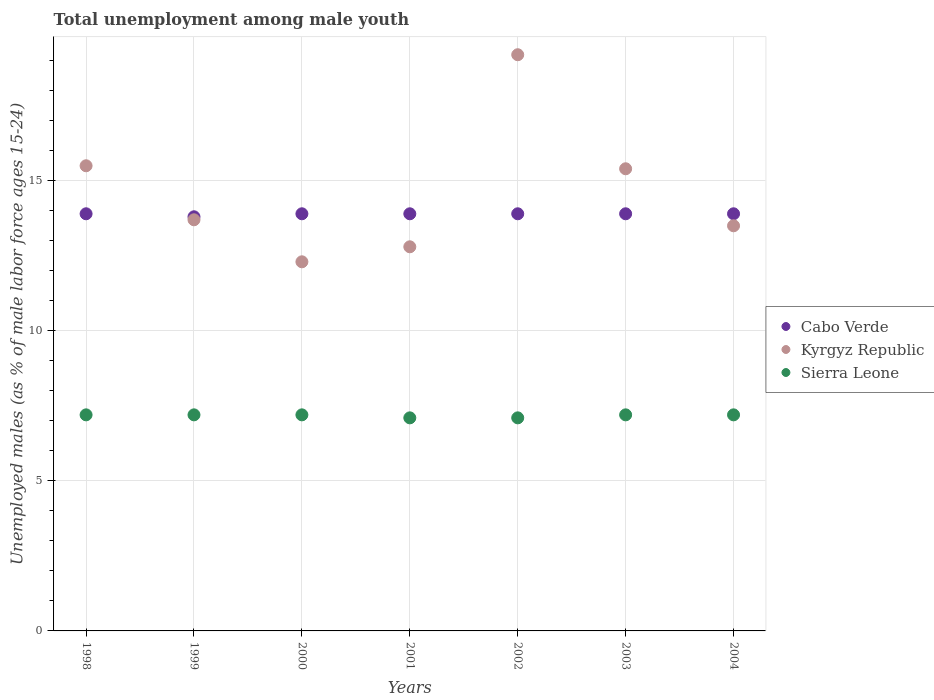Is the number of dotlines equal to the number of legend labels?
Ensure brevity in your answer.  Yes. What is the percentage of unemployed males in in Cabo Verde in 1998?
Ensure brevity in your answer.  13.9. Across all years, what is the maximum percentage of unemployed males in in Cabo Verde?
Your response must be concise. 13.9. Across all years, what is the minimum percentage of unemployed males in in Kyrgyz Republic?
Ensure brevity in your answer.  12.3. In which year was the percentage of unemployed males in in Sierra Leone maximum?
Offer a very short reply. 1998. In which year was the percentage of unemployed males in in Cabo Verde minimum?
Your response must be concise. 1999. What is the total percentage of unemployed males in in Cabo Verde in the graph?
Offer a very short reply. 97.2. What is the difference between the percentage of unemployed males in in Sierra Leone in 2000 and that in 2001?
Your answer should be very brief. 0.1. What is the difference between the percentage of unemployed males in in Cabo Verde in 2004 and the percentage of unemployed males in in Kyrgyz Republic in 2001?
Keep it short and to the point. 1.1. What is the average percentage of unemployed males in in Kyrgyz Republic per year?
Provide a short and direct response. 14.63. In the year 2003, what is the difference between the percentage of unemployed males in in Kyrgyz Republic and percentage of unemployed males in in Sierra Leone?
Offer a terse response. 8.2. In how many years, is the percentage of unemployed males in in Kyrgyz Republic greater than 4 %?
Give a very brief answer. 7. Is the percentage of unemployed males in in Kyrgyz Republic in 1999 less than that in 2001?
Ensure brevity in your answer.  No. What is the difference between the highest and the second highest percentage of unemployed males in in Cabo Verde?
Keep it short and to the point. 0. What is the difference between the highest and the lowest percentage of unemployed males in in Kyrgyz Republic?
Make the answer very short. 6.9. Is the sum of the percentage of unemployed males in in Cabo Verde in 2000 and 2002 greater than the maximum percentage of unemployed males in in Kyrgyz Republic across all years?
Your answer should be very brief. Yes. Is it the case that in every year, the sum of the percentage of unemployed males in in Sierra Leone and percentage of unemployed males in in Cabo Verde  is greater than the percentage of unemployed males in in Kyrgyz Republic?
Provide a short and direct response. Yes. How many dotlines are there?
Keep it short and to the point. 3. What is the difference between two consecutive major ticks on the Y-axis?
Offer a very short reply. 5. Are the values on the major ticks of Y-axis written in scientific E-notation?
Provide a short and direct response. No. Does the graph contain any zero values?
Provide a succinct answer. No. Does the graph contain grids?
Give a very brief answer. Yes. Where does the legend appear in the graph?
Offer a terse response. Center right. How many legend labels are there?
Provide a short and direct response. 3. How are the legend labels stacked?
Make the answer very short. Vertical. What is the title of the graph?
Offer a terse response. Total unemployment among male youth. What is the label or title of the X-axis?
Keep it short and to the point. Years. What is the label or title of the Y-axis?
Your answer should be compact. Unemployed males (as % of male labor force ages 15-24). What is the Unemployed males (as % of male labor force ages 15-24) in Cabo Verde in 1998?
Offer a very short reply. 13.9. What is the Unemployed males (as % of male labor force ages 15-24) of Sierra Leone in 1998?
Ensure brevity in your answer.  7.2. What is the Unemployed males (as % of male labor force ages 15-24) in Cabo Verde in 1999?
Provide a short and direct response. 13.8. What is the Unemployed males (as % of male labor force ages 15-24) of Kyrgyz Republic in 1999?
Give a very brief answer. 13.7. What is the Unemployed males (as % of male labor force ages 15-24) in Sierra Leone in 1999?
Offer a terse response. 7.2. What is the Unemployed males (as % of male labor force ages 15-24) of Cabo Verde in 2000?
Give a very brief answer. 13.9. What is the Unemployed males (as % of male labor force ages 15-24) of Kyrgyz Republic in 2000?
Provide a succinct answer. 12.3. What is the Unemployed males (as % of male labor force ages 15-24) of Sierra Leone in 2000?
Offer a terse response. 7.2. What is the Unemployed males (as % of male labor force ages 15-24) of Cabo Verde in 2001?
Provide a succinct answer. 13.9. What is the Unemployed males (as % of male labor force ages 15-24) of Kyrgyz Republic in 2001?
Keep it short and to the point. 12.8. What is the Unemployed males (as % of male labor force ages 15-24) in Sierra Leone in 2001?
Provide a succinct answer. 7.1. What is the Unemployed males (as % of male labor force ages 15-24) of Cabo Verde in 2002?
Keep it short and to the point. 13.9. What is the Unemployed males (as % of male labor force ages 15-24) of Kyrgyz Republic in 2002?
Provide a succinct answer. 19.2. What is the Unemployed males (as % of male labor force ages 15-24) of Sierra Leone in 2002?
Offer a very short reply. 7.1. What is the Unemployed males (as % of male labor force ages 15-24) in Cabo Verde in 2003?
Your response must be concise. 13.9. What is the Unemployed males (as % of male labor force ages 15-24) of Kyrgyz Republic in 2003?
Provide a succinct answer. 15.4. What is the Unemployed males (as % of male labor force ages 15-24) of Sierra Leone in 2003?
Make the answer very short. 7.2. What is the Unemployed males (as % of male labor force ages 15-24) in Cabo Verde in 2004?
Your answer should be very brief. 13.9. What is the Unemployed males (as % of male labor force ages 15-24) of Kyrgyz Republic in 2004?
Ensure brevity in your answer.  13.5. What is the Unemployed males (as % of male labor force ages 15-24) of Sierra Leone in 2004?
Make the answer very short. 7.2. Across all years, what is the maximum Unemployed males (as % of male labor force ages 15-24) of Cabo Verde?
Offer a terse response. 13.9. Across all years, what is the maximum Unemployed males (as % of male labor force ages 15-24) in Kyrgyz Republic?
Your answer should be very brief. 19.2. Across all years, what is the maximum Unemployed males (as % of male labor force ages 15-24) in Sierra Leone?
Your response must be concise. 7.2. Across all years, what is the minimum Unemployed males (as % of male labor force ages 15-24) in Cabo Verde?
Your answer should be compact. 13.8. Across all years, what is the minimum Unemployed males (as % of male labor force ages 15-24) in Kyrgyz Republic?
Give a very brief answer. 12.3. Across all years, what is the minimum Unemployed males (as % of male labor force ages 15-24) in Sierra Leone?
Make the answer very short. 7.1. What is the total Unemployed males (as % of male labor force ages 15-24) in Cabo Verde in the graph?
Offer a terse response. 97.2. What is the total Unemployed males (as % of male labor force ages 15-24) in Kyrgyz Republic in the graph?
Your answer should be very brief. 102.4. What is the total Unemployed males (as % of male labor force ages 15-24) of Sierra Leone in the graph?
Your answer should be very brief. 50.2. What is the difference between the Unemployed males (as % of male labor force ages 15-24) in Kyrgyz Republic in 1998 and that in 1999?
Your answer should be compact. 1.8. What is the difference between the Unemployed males (as % of male labor force ages 15-24) of Kyrgyz Republic in 1998 and that in 2000?
Keep it short and to the point. 3.2. What is the difference between the Unemployed males (as % of male labor force ages 15-24) of Cabo Verde in 1998 and that in 2001?
Your answer should be very brief. 0. What is the difference between the Unemployed males (as % of male labor force ages 15-24) of Kyrgyz Republic in 1998 and that in 2001?
Your response must be concise. 2.7. What is the difference between the Unemployed males (as % of male labor force ages 15-24) in Cabo Verde in 1998 and that in 2003?
Offer a terse response. 0. What is the difference between the Unemployed males (as % of male labor force ages 15-24) of Kyrgyz Republic in 1998 and that in 2003?
Provide a short and direct response. 0.1. What is the difference between the Unemployed males (as % of male labor force ages 15-24) of Kyrgyz Republic in 1998 and that in 2004?
Your answer should be very brief. 2. What is the difference between the Unemployed males (as % of male labor force ages 15-24) in Cabo Verde in 1999 and that in 2000?
Provide a succinct answer. -0.1. What is the difference between the Unemployed males (as % of male labor force ages 15-24) in Kyrgyz Republic in 1999 and that in 2000?
Make the answer very short. 1.4. What is the difference between the Unemployed males (as % of male labor force ages 15-24) in Sierra Leone in 1999 and that in 2000?
Offer a terse response. 0. What is the difference between the Unemployed males (as % of male labor force ages 15-24) of Kyrgyz Republic in 1999 and that in 2001?
Provide a succinct answer. 0.9. What is the difference between the Unemployed males (as % of male labor force ages 15-24) in Sierra Leone in 1999 and that in 2002?
Keep it short and to the point. 0.1. What is the difference between the Unemployed males (as % of male labor force ages 15-24) in Cabo Verde in 1999 and that in 2003?
Provide a succinct answer. -0.1. What is the difference between the Unemployed males (as % of male labor force ages 15-24) in Kyrgyz Republic in 1999 and that in 2003?
Your answer should be very brief. -1.7. What is the difference between the Unemployed males (as % of male labor force ages 15-24) of Cabo Verde in 1999 and that in 2004?
Give a very brief answer. -0.1. What is the difference between the Unemployed males (as % of male labor force ages 15-24) of Cabo Verde in 2000 and that in 2001?
Your answer should be compact. 0. What is the difference between the Unemployed males (as % of male labor force ages 15-24) of Sierra Leone in 2000 and that in 2001?
Provide a succinct answer. 0.1. What is the difference between the Unemployed males (as % of male labor force ages 15-24) of Sierra Leone in 2000 and that in 2002?
Provide a short and direct response. 0.1. What is the difference between the Unemployed males (as % of male labor force ages 15-24) in Sierra Leone in 2000 and that in 2003?
Give a very brief answer. 0. What is the difference between the Unemployed males (as % of male labor force ages 15-24) in Cabo Verde in 2000 and that in 2004?
Provide a short and direct response. 0. What is the difference between the Unemployed males (as % of male labor force ages 15-24) of Sierra Leone in 2000 and that in 2004?
Your response must be concise. 0. What is the difference between the Unemployed males (as % of male labor force ages 15-24) in Kyrgyz Republic in 2001 and that in 2002?
Offer a very short reply. -6.4. What is the difference between the Unemployed males (as % of male labor force ages 15-24) of Sierra Leone in 2001 and that in 2002?
Your answer should be very brief. 0. What is the difference between the Unemployed males (as % of male labor force ages 15-24) of Sierra Leone in 2001 and that in 2004?
Your answer should be compact. -0.1. What is the difference between the Unemployed males (as % of male labor force ages 15-24) of Cabo Verde in 2002 and that in 2003?
Keep it short and to the point. 0. What is the difference between the Unemployed males (as % of male labor force ages 15-24) of Kyrgyz Republic in 2002 and that in 2003?
Ensure brevity in your answer.  3.8. What is the difference between the Unemployed males (as % of male labor force ages 15-24) in Cabo Verde in 2002 and that in 2004?
Give a very brief answer. 0. What is the difference between the Unemployed males (as % of male labor force ages 15-24) in Kyrgyz Republic in 2002 and that in 2004?
Provide a short and direct response. 5.7. What is the difference between the Unemployed males (as % of male labor force ages 15-24) of Sierra Leone in 2002 and that in 2004?
Your answer should be very brief. -0.1. What is the difference between the Unemployed males (as % of male labor force ages 15-24) of Sierra Leone in 2003 and that in 2004?
Offer a very short reply. 0. What is the difference between the Unemployed males (as % of male labor force ages 15-24) in Cabo Verde in 1998 and the Unemployed males (as % of male labor force ages 15-24) in Kyrgyz Republic in 1999?
Keep it short and to the point. 0.2. What is the difference between the Unemployed males (as % of male labor force ages 15-24) of Kyrgyz Republic in 1998 and the Unemployed males (as % of male labor force ages 15-24) of Sierra Leone in 1999?
Ensure brevity in your answer.  8.3. What is the difference between the Unemployed males (as % of male labor force ages 15-24) of Cabo Verde in 1998 and the Unemployed males (as % of male labor force ages 15-24) of Sierra Leone in 2000?
Your answer should be compact. 6.7. What is the difference between the Unemployed males (as % of male labor force ages 15-24) in Kyrgyz Republic in 1998 and the Unemployed males (as % of male labor force ages 15-24) in Sierra Leone in 2000?
Offer a very short reply. 8.3. What is the difference between the Unemployed males (as % of male labor force ages 15-24) of Kyrgyz Republic in 1998 and the Unemployed males (as % of male labor force ages 15-24) of Sierra Leone in 2001?
Give a very brief answer. 8.4. What is the difference between the Unemployed males (as % of male labor force ages 15-24) in Cabo Verde in 1998 and the Unemployed males (as % of male labor force ages 15-24) in Kyrgyz Republic in 2002?
Make the answer very short. -5.3. What is the difference between the Unemployed males (as % of male labor force ages 15-24) of Cabo Verde in 1998 and the Unemployed males (as % of male labor force ages 15-24) of Sierra Leone in 2002?
Provide a succinct answer. 6.8. What is the difference between the Unemployed males (as % of male labor force ages 15-24) of Cabo Verde in 1998 and the Unemployed males (as % of male labor force ages 15-24) of Kyrgyz Republic in 2003?
Offer a terse response. -1.5. What is the difference between the Unemployed males (as % of male labor force ages 15-24) of Cabo Verde in 1998 and the Unemployed males (as % of male labor force ages 15-24) of Sierra Leone in 2003?
Your answer should be compact. 6.7. What is the difference between the Unemployed males (as % of male labor force ages 15-24) in Cabo Verde in 1998 and the Unemployed males (as % of male labor force ages 15-24) in Kyrgyz Republic in 2004?
Keep it short and to the point. 0.4. What is the difference between the Unemployed males (as % of male labor force ages 15-24) of Kyrgyz Republic in 1998 and the Unemployed males (as % of male labor force ages 15-24) of Sierra Leone in 2004?
Your answer should be very brief. 8.3. What is the difference between the Unemployed males (as % of male labor force ages 15-24) of Kyrgyz Republic in 1999 and the Unemployed males (as % of male labor force ages 15-24) of Sierra Leone in 2000?
Give a very brief answer. 6.5. What is the difference between the Unemployed males (as % of male labor force ages 15-24) of Cabo Verde in 1999 and the Unemployed males (as % of male labor force ages 15-24) of Sierra Leone in 2001?
Keep it short and to the point. 6.7. What is the difference between the Unemployed males (as % of male labor force ages 15-24) in Cabo Verde in 1999 and the Unemployed males (as % of male labor force ages 15-24) in Sierra Leone in 2002?
Provide a succinct answer. 6.7. What is the difference between the Unemployed males (as % of male labor force ages 15-24) in Kyrgyz Republic in 1999 and the Unemployed males (as % of male labor force ages 15-24) in Sierra Leone in 2002?
Provide a short and direct response. 6.6. What is the difference between the Unemployed males (as % of male labor force ages 15-24) in Kyrgyz Republic in 1999 and the Unemployed males (as % of male labor force ages 15-24) in Sierra Leone in 2003?
Offer a very short reply. 6.5. What is the difference between the Unemployed males (as % of male labor force ages 15-24) in Cabo Verde in 1999 and the Unemployed males (as % of male labor force ages 15-24) in Kyrgyz Republic in 2004?
Provide a succinct answer. 0.3. What is the difference between the Unemployed males (as % of male labor force ages 15-24) of Kyrgyz Republic in 1999 and the Unemployed males (as % of male labor force ages 15-24) of Sierra Leone in 2004?
Make the answer very short. 6.5. What is the difference between the Unemployed males (as % of male labor force ages 15-24) of Cabo Verde in 2000 and the Unemployed males (as % of male labor force ages 15-24) of Sierra Leone in 2001?
Your answer should be very brief. 6.8. What is the difference between the Unemployed males (as % of male labor force ages 15-24) in Kyrgyz Republic in 2000 and the Unemployed males (as % of male labor force ages 15-24) in Sierra Leone in 2001?
Offer a terse response. 5.2. What is the difference between the Unemployed males (as % of male labor force ages 15-24) of Cabo Verde in 2000 and the Unemployed males (as % of male labor force ages 15-24) of Kyrgyz Republic in 2002?
Your response must be concise. -5.3. What is the difference between the Unemployed males (as % of male labor force ages 15-24) of Kyrgyz Republic in 2000 and the Unemployed males (as % of male labor force ages 15-24) of Sierra Leone in 2002?
Offer a terse response. 5.2. What is the difference between the Unemployed males (as % of male labor force ages 15-24) of Cabo Verde in 2000 and the Unemployed males (as % of male labor force ages 15-24) of Sierra Leone in 2003?
Give a very brief answer. 6.7. What is the difference between the Unemployed males (as % of male labor force ages 15-24) in Kyrgyz Republic in 2000 and the Unemployed males (as % of male labor force ages 15-24) in Sierra Leone in 2003?
Make the answer very short. 5.1. What is the difference between the Unemployed males (as % of male labor force ages 15-24) in Cabo Verde in 2000 and the Unemployed males (as % of male labor force ages 15-24) in Kyrgyz Republic in 2004?
Offer a very short reply. 0.4. What is the difference between the Unemployed males (as % of male labor force ages 15-24) of Cabo Verde in 2000 and the Unemployed males (as % of male labor force ages 15-24) of Sierra Leone in 2004?
Your response must be concise. 6.7. What is the difference between the Unemployed males (as % of male labor force ages 15-24) of Cabo Verde in 2001 and the Unemployed males (as % of male labor force ages 15-24) of Kyrgyz Republic in 2002?
Keep it short and to the point. -5.3. What is the difference between the Unemployed males (as % of male labor force ages 15-24) in Cabo Verde in 2001 and the Unemployed males (as % of male labor force ages 15-24) in Sierra Leone in 2002?
Give a very brief answer. 6.8. What is the difference between the Unemployed males (as % of male labor force ages 15-24) of Kyrgyz Republic in 2001 and the Unemployed males (as % of male labor force ages 15-24) of Sierra Leone in 2002?
Offer a very short reply. 5.7. What is the difference between the Unemployed males (as % of male labor force ages 15-24) of Cabo Verde in 2001 and the Unemployed males (as % of male labor force ages 15-24) of Kyrgyz Republic in 2003?
Offer a terse response. -1.5. What is the difference between the Unemployed males (as % of male labor force ages 15-24) of Cabo Verde in 2001 and the Unemployed males (as % of male labor force ages 15-24) of Kyrgyz Republic in 2004?
Provide a short and direct response. 0.4. What is the difference between the Unemployed males (as % of male labor force ages 15-24) of Cabo Verde in 2001 and the Unemployed males (as % of male labor force ages 15-24) of Sierra Leone in 2004?
Offer a terse response. 6.7. What is the difference between the Unemployed males (as % of male labor force ages 15-24) of Kyrgyz Republic in 2001 and the Unemployed males (as % of male labor force ages 15-24) of Sierra Leone in 2004?
Provide a short and direct response. 5.6. What is the difference between the Unemployed males (as % of male labor force ages 15-24) of Cabo Verde in 2002 and the Unemployed males (as % of male labor force ages 15-24) of Kyrgyz Republic in 2003?
Give a very brief answer. -1.5. What is the difference between the Unemployed males (as % of male labor force ages 15-24) in Kyrgyz Republic in 2002 and the Unemployed males (as % of male labor force ages 15-24) in Sierra Leone in 2003?
Provide a short and direct response. 12. What is the difference between the Unemployed males (as % of male labor force ages 15-24) of Cabo Verde in 2002 and the Unemployed males (as % of male labor force ages 15-24) of Kyrgyz Republic in 2004?
Offer a very short reply. 0.4. What is the difference between the Unemployed males (as % of male labor force ages 15-24) in Cabo Verde in 2002 and the Unemployed males (as % of male labor force ages 15-24) in Sierra Leone in 2004?
Your answer should be very brief. 6.7. What is the difference between the Unemployed males (as % of male labor force ages 15-24) of Kyrgyz Republic in 2002 and the Unemployed males (as % of male labor force ages 15-24) of Sierra Leone in 2004?
Your answer should be very brief. 12. What is the difference between the Unemployed males (as % of male labor force ages 15-24) in Cabo Verde in 2003 and the Unemployed males (as % of male labor force ages 15-24) in Kyrgyz Republic in 2004?
Your response must be concise. 0.4. What is the difference between the Unemployed males (as % of male labor force ages 15-24) in Cabo Verde in 2003 and the Unemployed males (as % of male labor force ages 15-24) in Sierra Leone in 2004?
Give a very brief answer. 6.7. What is the average Unemployed males (as % of male labor force ages 15-24) of Cabo Verde per year?
Your answer should be very brief. 13.89. What is the average Unemployed males (as % of male labor force ages 15-24) of Kyrgyz Republic per year?
Ensure brevity in your answer.  14.63. What is the average Unemployed males (as % of male labor force ages 15-24) of Sierra Leone per year?
Keep it short and to the point. 7.17. In the year 1998, what is the difference between the Unemployed males (as % of male labor force ages 15-24) of Kyrgyz Republic and Unemployed males (as % of male labor force ages 15-24) of Sierra Leone?
Make the answer very short. 8.3. In the year 1999, what is the difference between the Unemployed males (as % of male labor force ages 15-24) in Cabo Verde and Unemployed males (as % of male labor force ages 15-24) in Kyrgyz Republic?
Offer a terse response. 0.1. In the year 2000, what is the difference between the Unemployed males (as % of male labor force ages 15-24) of Cabo Verde and Unemployed males (as % of male labor force ages 15-24) of Kyrgyz Republic?
Your answer should be very brief. 1.6. In the year 2000, what is the difference between the Unemployed males (as % of male labor force ages 15-24) of Cabo Verde and Unemployed males (as % of male labor force ages 15-24) of Sierra Leone?
Provide a short and direct response. 6.7. In the year 2001, what is the difference between the Unemployed males (as % of male labor force ages 15-24) in Cabo Verde and Unemployed males (as % of male labor force ages 15-24) in Kyrgyz Republic?
Your answer should be compact. 1.1. In the year 2001, what is the difference between the Unemployed males (as % of male labor force ages 15-24) of Cabo Verde and Unemployed males (as % of male labor force ages 15-24) of Sierra Leone?
Your response must be concise. 6.8. In the year 2001, what is the difference between the Unemployed males (as % of male labor force ages 15-24) in Kyrgyz Republic and Unemployed males (as % of male labor force ages 15-24) in Sierra Leone?
Provide a short and direct response. 5.7. In the year 2002, what is the difference between the Unemployed males (as % of male labor force ages 15-24) of Cabo Verde and Unemployed males (as % of male labor force ages 15-24) of Kyrgyz Republic?
Ensure brevity in your answer.  -5.3. In the year 2002, what is the difference between the Unemployed males (as % of male labor force ages 15-24) of Kyrgyz Republic and Unemployed males (as % of male labor force ages 15-24) of Sierra Leone?
Provide a short and direct response. 12.1. In the year 2003, what is the difference between the Unemployed males (as % of male labor force ages 15-24) of Cabo Verde and Unemployed males (as % of male labor force ages 15-24) of Kyrgyz Republic?
Provide a short and direct response. -1.5. In the year 2003, what is the difference between the Unemployed males (as % of male labor force ages 15-24) in Cabo Verde and Unemployed males (as % of male labor force ages 15-24) in Sierra Leone?
Give a very brief answer. 6.7. In the year 2003, what is the difference between the Unemployed males (as % of male labor force ages 15-24) in Kyrgyz Republic and Unemployed males (as % of male labor force ages 15-24) in Sierra Leone?
Provide a succinct answer. 8.2. In the year 2004, what is the difference between the Unemployed males (as % of male labor force ages 15-24) of Cabo Verde and Unemployed males (as % of male labor force ages 15-24) of Kyrgyz Republic?
Make the answer very short. 0.4. In the year 2004, what is the difference between the Unemployed males (as % of male labor force ages 15-24) of Cabo Verde and Unemployed males (as % of male labor force ages 15-24) of Sierra Leone?
Your response must be concise. 6.7. In the year 2004, what is the difference between the Unemployed males (as % of male labor force ages 15-24) in Kyrgyz Republic and Unemployed males (as % of male labor force ages 15-24) in Sierra Leone?
Offer a terse response. 6.3. What is the ratio of the Unemployed males (as % of male labor force ages 15-24) in Cabo Verde in 1998 to that in 1999?
Ensure brevity in your answer.  1.01. What is the ratio of the Unemployed males (as % of male labor force ages 15-24) in Kyrgyz Republic in 1998 to that in 1999?
Your answer should be compact. 1.13. What is the ratio of the Unemployed males (as % of male labor force ages 15-24) of Kyrgyz Republic in 1998 to that in 2000?
Your response must be concise. 1.26. What is the ratio of the Unemployed males (as % of male labor force ages 15-24) of Kyrgyz Republic in 1998 to that in 2001?
Your answer should be very brief. 1.21. What is the ratio of the Unemployed males (as % of male labor force ages 15-24) of Sierra Leone in 1998 to that in 2001?
Give a very brief answer. 1.01. What is the ratio of the Unemployed males (as % of male labor force ages 15-24) in Cabo Verde in 1998 to that in 2002?
Your answer should be compact. 1. What is the ratio of the Unemployed males (as % of male labor force ages 15-24) in Kyrgyz Republic in 1998 to that in 2002?
Keep it short and to the point. 0.81. What is the ratio of the Unemployed males (as % of male labor force ages 15-24) in Sierra Leone in 1998 to that in 2002?
Your answer should be compact. 1.01. What is the ratio of the Unemployed males (as % of male labor force ages 15-24) in Kyrgyz Republic in 1998 to that in 2003?
Give a very brief answer. 1.01. What is the ratio of the Unemployed males (as % of male labor force ages 15-24) in Kyrgyz Republic in 1998 to that in 2004?
Your answer should be very brief. 1.15. What is the ratio of the Unemployed males (as % of male labor force ages 15-24) of Kyrgyz Republic in 1999 to that in 2000?
Offer a very short reply. 1.11. What is the ratio of the Unemployed males (as % of male labor force ages 15-24) in Sierra Leone in 1999 to that in 2000?
Your answer should be compact. 1. What is the ratio of the Unemployed males (as % of male labor force ages 15-24) in Cabo Verde in 1999 to that in 2001?
Provide a short and direct response. 0.99. What is the ratio of the Unemployed males (as % of male labor force ages 15-24) of Kyrgyz Republic in 1999 to that in 2001?
Offer a terse response. 1.07. What is the ratio of the Unemployed males (as % of male labor force ages 15-24) in Sierra Leone in 1999 to that in 2001?
Keep it short and to the point. 1.01. What is the ratio of the Unemployed males (as % of male labor force ages 15-24) in Kyrgyz Republic in 1999 to that in 2002?
Give a very brief answer. 0.71. What is the ratio of the Unemployed males (as % of male labor force ages 15-24) of Sierra Leone in 1999 to that in 2002?
Your answer should be compact. 1.01. What is the ratio of the Unemployed males (as % of male labor force ages 15-24) of Cabo Verde in 1999 to that in 2003?
Provide a short and direct response. 0.99. What is the ratio of the Unemployed males (as % of male labor force ages 15-24) of Kyrgyz Republic in 1999 to that in 2003?
Your answer should be compact. 0.89. What is the ratio of the Unemployed males (as % of male labor force ages 15-24) of Sierra Leone in 1999 to that in 2003?
Offer a very short reply. 1. What is the ratio of the Unemployed males (as % of male labor force ages 15-24) in Cabo Verde in 1999 to that in 2004?
Provide a succinct answer. 0.99. What is the ratio of the Unemployed males (as % of male labor force ages 15-24) in Kyrgyz Republic in 1999 to that in 2004?
Offer a terse response. 1.01. What is the ratio of the Unemployed males (as % of male labor force ages 15-24) in Sierra Leone in 1999 to that in 2004?
Give a very brief answer. 1. What is the ratio of the Unemployed males (as % of male labor force ages 15-24) of Kyrgyz Republic in 2000 to that in 2001?
Provide a succinct answer. 0.96. What is the ratio of the Unemployed males (as % of male labor force ages 15-24) in Sierra Leone in 2000 to that in 2001?
Keep it short and to the point. 1.01. What is the ratio of the Unemployed males (as % of male labor force ages 15-24) in Kyrgyz Republic in 2000 to that in 2002?
Your answer should be very brief. 0.64. What is the ratio of the Unemployed males (as % of male labor force ages 15-24) of Sierra Leone in 2000 to that in 2002?
Give a very brief answer. 1.01. What is the ratio of the Unemployed males (as % of male labor force ages 15-24) of Kyrgyz Republic in 2000 to that in 2003?
Offer a terse response. 0.8. What is the ratio of the Unemployed males (as % of male labor force ages 15-24) in Cabo Verde in 2000 to that in 2004?
Make the answer very short. 1. What is the ratio of the Unemployed males (as % of male labor force ages 15-24) in Kyrgyz Republic in 2000 to that in 2004?
Provide a short and direct response. 0.91. What is the ratio of the Unemployed males (as % of male labor force ages 15-24) of Sierra Leone in 2000 to that in 2004?
Your answer should be compact. 1. What is the ratio of the Unemployed males (as % of male labor force ages 15-24) in Kyrgyz Republic in 2001 to that in 2002?
Keep it short and to the point. 0.67. What is the ratio of the Unemployed males (as % of male labor force ages 15-24) of Sierra Leone in 2001 to that in 2002?
Provide a short and direct response. 1. What is the ratio of the Unemployed males (as % of male labor force ages 15-24) in Cabo Verde in 2001 to that in 2003?
Make the answer very short. 1. What is the ratio of the Unemployed males (as % of male labor force ages 15-24) of Kyrgyz Republic in 2001 to that in 2003?
Your answer should be compact. 0.83. What is the ratio of the Unemployed males (as % of male labor force ages 15-24) in Sierra Leone in 2001 to that in 2003?
Your answer should be very brief. 0.99. What is the ratio of the Unemployed males (as % of male labor force ages 15-24) in Cabo Verde in 2001 to that in 2004?
Make the answer very short. 1. What is the ratio of the Unemployed males (as % of male labor force ages 15-24) of Kyrgyz Republic in 2001 to that in 2004?
Your response must be concise. 0.95. What is the ratio of the Unemployed males (as % of male labor force ages 15-24) of Sierra Leone in 2001 to that in 2004?
Offer a terse response. 0.99. What is the ratio of the Unemployed males (as % of male labor force ages 15-24) in Cabo Verde in 2002 to that in 2003?
Provide a short and direct response. 1. What is the ratio of the Unemployed males (as % of male labor force ages 15-24) in Kyrgyz Republic in 2002 to that in 2003?
Your response must be concise. 1.25. What is the ratio of the Unemployed males (as % of male labor force ages 15-24) of Sierra Leone in 2002 to that in 2003?
Provide a short and direct response. 0.99. What is the ratio of the Unemployed males (as % of male labor force ages 15-24) of Cabo Verde in 2002 to that in 2004?
Your response must be concise. 1. What is the ratio of the Unemployed males (as % of male labor force ages 15-24) in Kyrgyz Republic in 2002 to that in 2004?
Your answer should be compact. 1.42. What is the ratio of the Unemployed males (as % of male labor force ages 15-24) in Sierra Leone in 2002 to that in 2004?
Ensure brevity in your answer.  0.99. What is the ratio of the Unemployed males (as % of male labor force ages 15-24) in Kyrgyz Republic in 2003 to that in 2004?
Provide a short and direct response. 1.14. What is the ratio of the Unemployed males (as % of male labor force ages 15-24) of Sierra Leone in 2003 to that in 2004?
Offer a terse response. 1. What is the difference between the highest and the second highest Unemployed males (as % of male labor force ages 15-24) of Cabo Verde?
Offer a terse response. 0. What is the difference between the highest and the second highest Unemployed males (as % of male labor force ages 15-24) in Sierra Leone?
Make the answer very short. 0. What is the difference between the highest and the lowest Unemployed males (as % of male labor force ages 15-24) of Cabo Verde?
Offer a terse response. 0.1. 